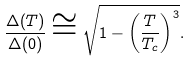<formula> <loc_0><loc_0><loc_500><loc_500>\frac { \Delta ( T ) } { \Delta ( 0 ) } \cong \sqrt { 1 - \left ( \frac { T } { T _ { c } } \right ) ^ { 3 } } .</formula> 